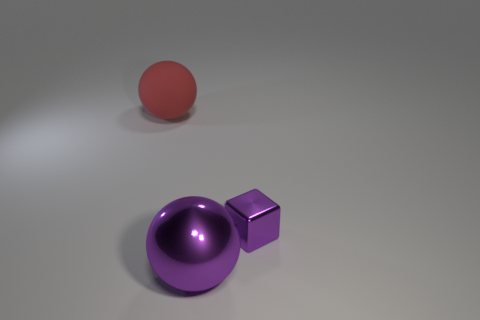What shape is the red thing that is the same size as the purple metallic sphere?
Give a very brief answer. Sphere. How many objects are spheres left of the big purple shiny sphere or red rubber cylinders?
Offer a terse response. 1. What number of other objects are the same material as the big purple ball?
Make the answer very short. 1. What shape is the small thing that is the same color as the large metallic sphere?
Offer a terse response. Cube. There is a object that is to the right of the big purple sphere; how big is it?
Give a very brief answer. Small. There is a small object that is the same material as the large purple thing; what is its shape?
Ensure brevity in your answer.  Cube. Is the material of the tiny block the same as the ball right of the red ball?
Your answer should be compact. Yes. Do the purple object that is right of the metal sphere and the big matte object have the same shape?
Your answer should be compact. No. What material is the other purple object that is the same shape as the big rubber thing?
Your answer should be compact. Metal. Do the small purple object and the purple object that is on the left side of the tiny cube have the same shape?
Keep it short and to the point. No. 